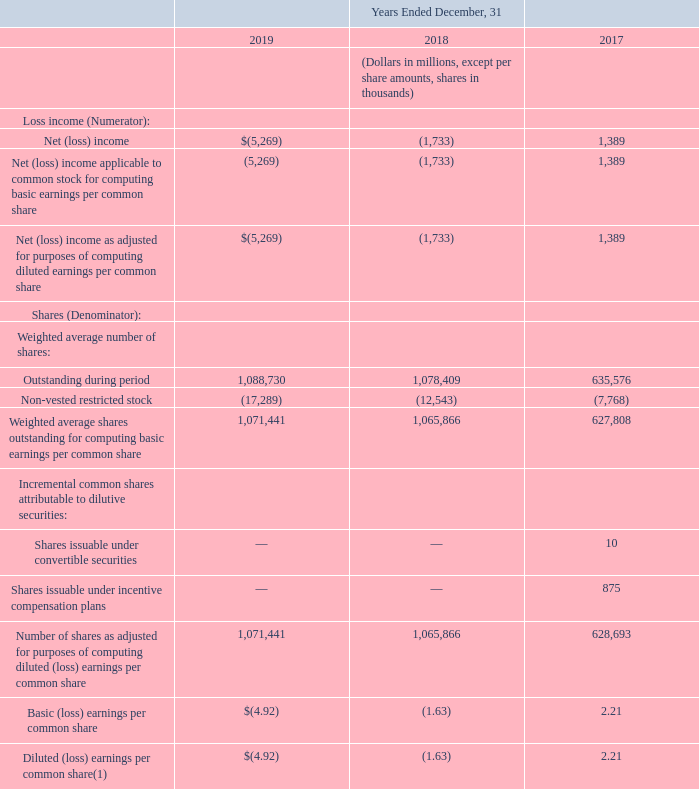(13) (Loss) Earnings Per Common Share
Basic and diluted (loss) earnings per common share for the years ended December 31, 2019, 2018 and 2017 were calculated as follows:
(1) For the year ended December 31, 2019 and December 31, 2018, we excluded from the calculation of diluted loss per share 3.0 million shares and 4.6 million shares, respectively, potentially issuable under incentive compensation plans or convertible securities, as their effect, if included, would have been anti-dilutive.
Our calculation of diluted (loss) earnings per common share excludes shares of common stock that are issuable upon exercise of stock options when the exercise price is greater than the average market price of our common stock. We also exclude unvested restricted stock awards that are antidilutive as a result of unrecognized compensation cost. Such shares were 6.8 million, 2.7 million and 4.7 million for 2019, 2018 and 2017, respectively.
For the Diluted (loss) earnings per common share, what was excluded for the years 2018 and 2019? We excluded from the calculation of diluted loss per share 3.0 million shares and 4.6 million shares, respectively, potentially issuable under incentive compensation plans or convertible securities, as their effect, if included, would have been anti-dilutive. What was excluded as a result of unrecognized compensation cost? Unvested restricted stock awards that are antidilutive. In which years were the unvested restricted stock awards that are antidilutive excluded? 2019, 2018, 2017. In which year was the Number of shares as adjusted for purposes of computing diluted (loss) earnings per common share  the largest? 1,071,441>1,065,866>628,693
Answer: 2019. What is the total amount of unvested restricted stock awards that are antidilutive excluded in 2017, 2018 and 2019?
Answer scale should be: million. 6.8+2.7+4.7
Answer: 14.2. What is the average annual amount of unvested restricted stock awards that are antidilutive excluded in 2017, 2018 and 2019?
Answer scale should be: million. (6.8+2.7+4.7)/3
Answer: 4.73. 